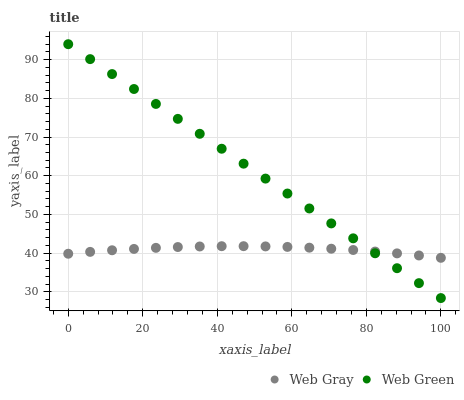Does Web Gray have the minimum area under the curve?
Answer yes or no. Yes. Does Web Green have the maximum area under the curve?
Answer yes or no. Yes. Does Web Green have the minimum area under the curve?
Answer yes or no. No. Is Web Green the smoothest?
Answer yes or no. Yes. Is Web Gray the roughest?
Answer yes or no. Yes. Is Web Green the roughest?
Answer yes or no. No. Does Web Green have the lowest value?
Answer yes or no. Yes. Does Web Green have the highest value?
Answer yes or no. Yes. Does Web Gray intersect Web Green?
Answer yes or no. Yes. Is Web Gray less than Web Green?
Answer yes or no. No. Is Web Gray greater than Web Green?
Answer yes or no. No. 